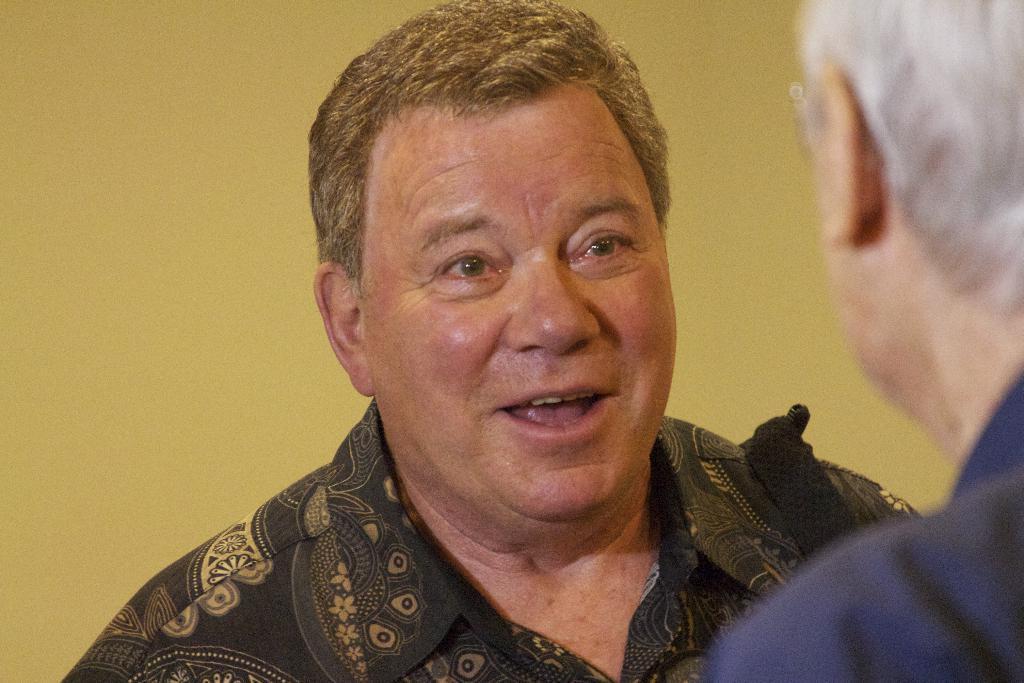Please provide a concise description of this image. In this picture there are two men. In the background of the image it is yellow. 